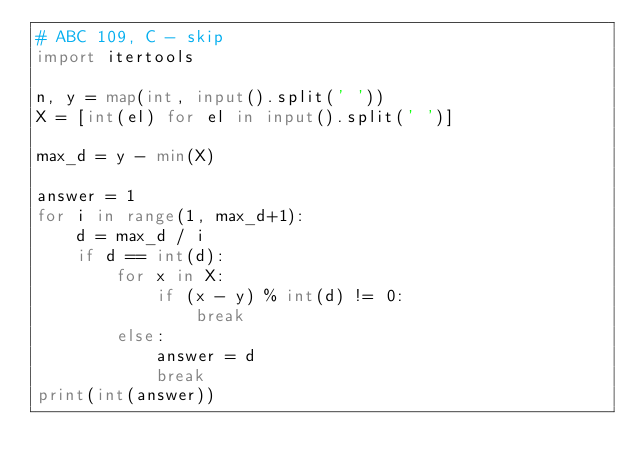<code> <loc_0><loc_0><loc_500><loc_500><_Python_># ABC 109, C - skip
import itertools

n, y = map(int, input().split(' '))
X = [int(el) for el in input().split(' ')]

max_d = y - min(X)

answer = 1
for i in range(1, max_d+1):
    d = max_d / i
    if d == int(d):
        for x in X:
            if (x - y) % int(d) != 0:
                break
        else:
            answer = d
            break
print(int(answer))


</code> 